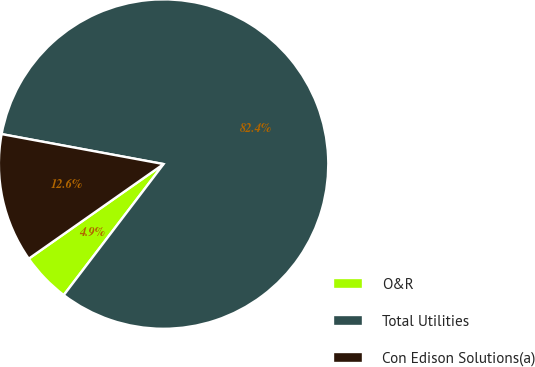Convert chart to OTSL. <chart><loc_0><loc_0><loc_500><loc_500><pie_chart><fcel>O&R<fcel>Total Utilities<fcel>Con Edison Solutions(a)<nl><fcel>4.9%<fcel>82.45%<fcel>12.65%<nl></chart> 